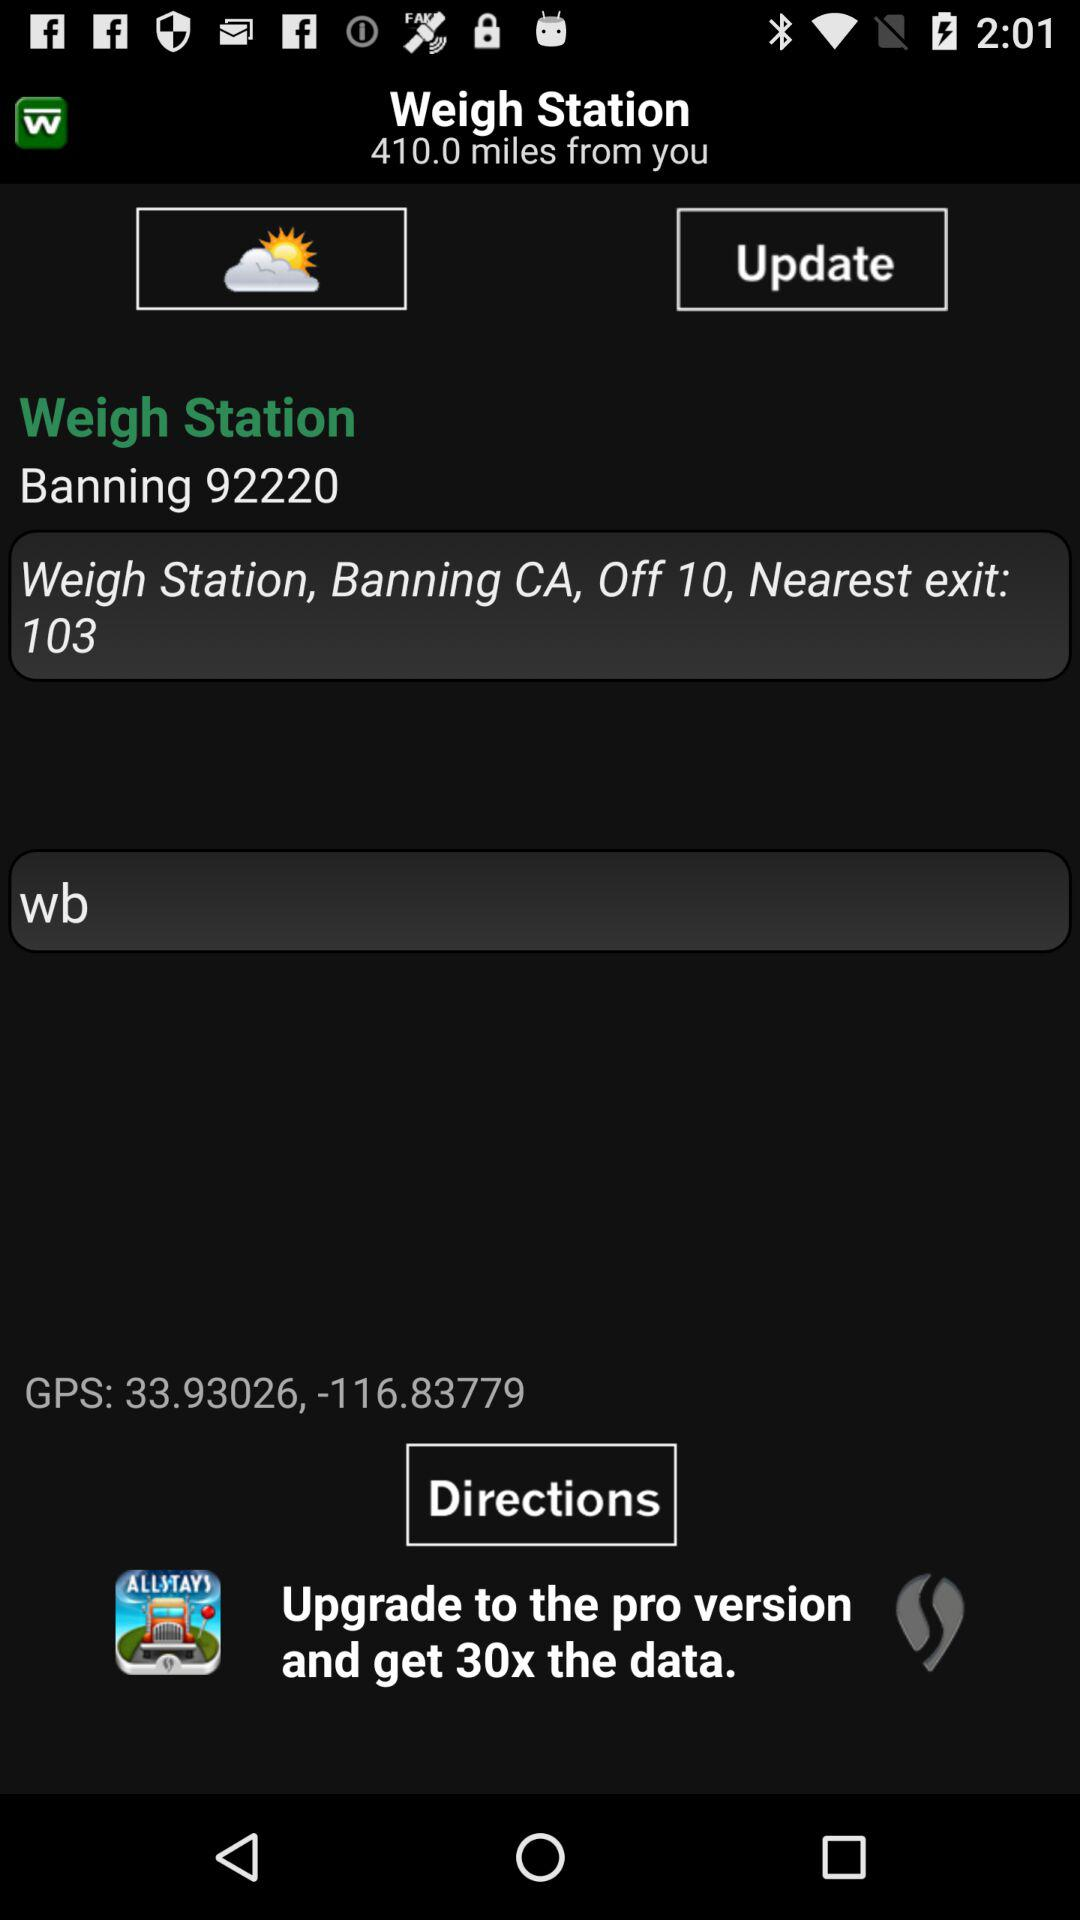What is the zip code of the weigh station?
Answer the question using a single word or phrase. 92220 